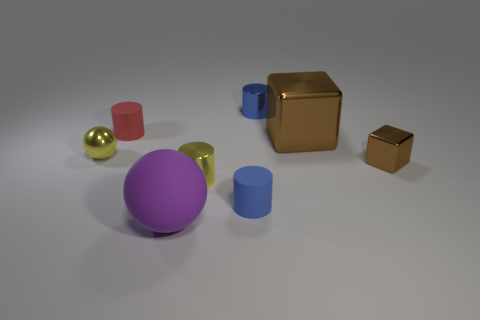The other object that is the same color as the large metal thing is what size?
Ensure brevity in your answer.  Small. There is a brown thing that is made of the same material as the small cube; what is its size?
Your answer should be compact. Large. What number of objects are brown things behind the tiny brown metal thing or big purple matte balls?
Keep it short and to the point. 2. There is a metallic cylinder that is in front of the tiny red matte cylinder; is its color the same as the tiny shiny ball?
Your answer should be compact. Yes. There is another brown metal thing that is the same shape as the tiny brown object; what size is it?
Offer a terse response. Large. There is a tiny matte thing that is on the left side of the matte thing on the right side of the metal cylinder that is in front of the red rubber cylinder; what color is it?
Offer a terse response. Red. Is the material of the small red thing the same as the large purple sphere?
Your answer should be compact. Yes. There is a metallic cylinder left of the blue cylinder to the left of the tiny blue metal cylinder; are there any yellow cylinders that are behind it?
Provide a succinct answer. No. Do the tiny shiny ball and the matte ball have the same color?
Provide a short and direct response. No. Is the number of big objects less than the number of cylinders?
Provide a short and direct response. Yes. 